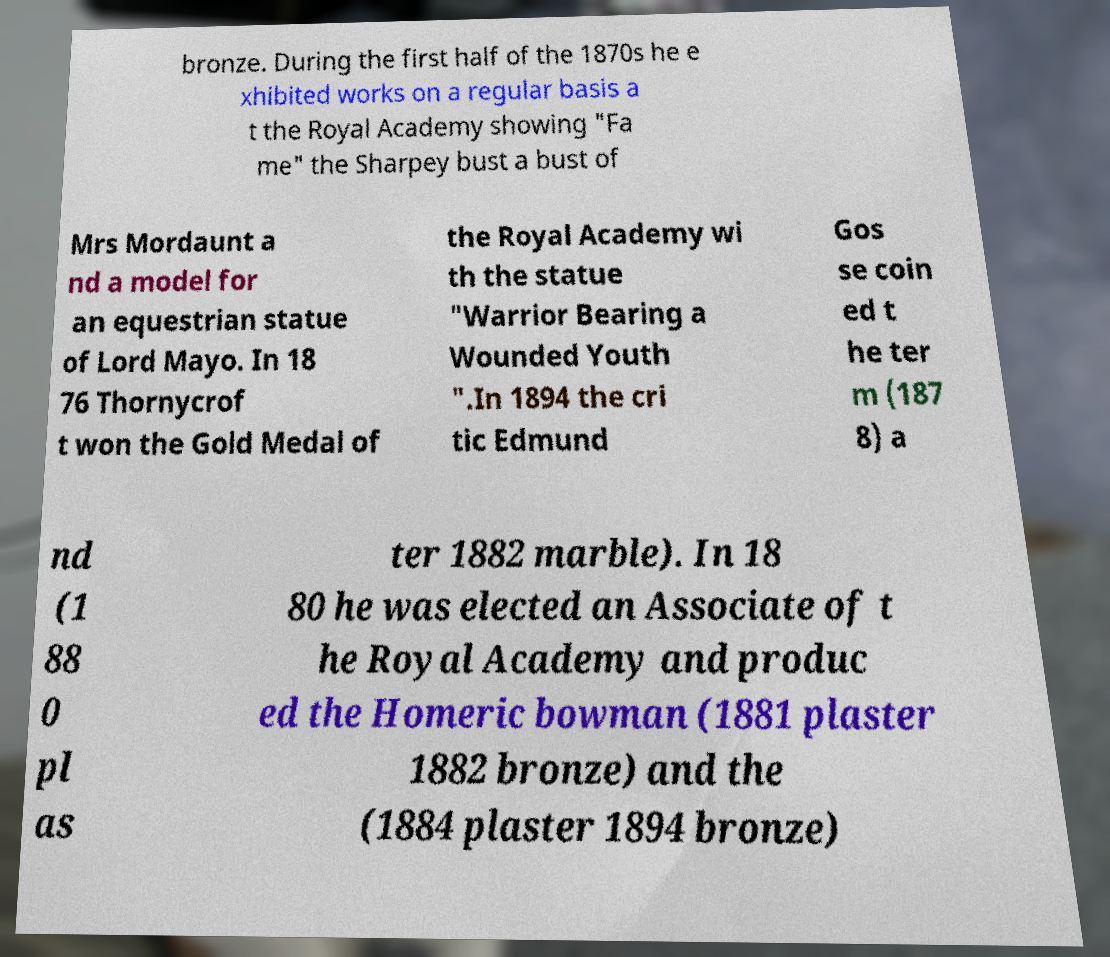Can you read and provide the text displayed in the image?This photo seems to have some interesting text. Can you extract and type it out for me? bronze. During the first half of the 1870s he e xhibited works on a regular basis a t the Royal Academy showing "Fa me" the Sharpey bust a bust of Mrs Mordaunt a nd a model for an equestrian statue of Lord Mayo. In 18 76 Thornycrof t won the Gold Medal of the Royal Academy wi th the statue "Warrior Bearing a Wounded Youth ".In 1894 the cri tic Edmund Gos se coin ed t he ter m (187 8) a nd (1 88 0 pl as ter 1882 marble). In 18 80 he was elected an Associate of t he Royal Academy and produc ed the Homeric bowman (1881 plaster 1882 bronze) and the (1884 plaster 1894 bronze) 